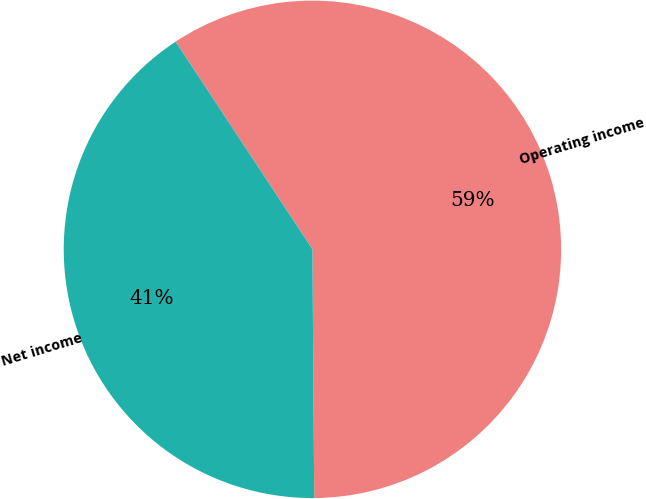Convert chart. <chart><loc_0><loc_0><loc_500><loc_500><pie_chart><fcel>Operating income<fcel>Net income<nl><fcel>59.16%<fcel>40.84%<nl></chart> 